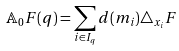Convert formula to latex. <formula><loc_0><loc_0><loc_500><loc_500>\mathbb { A } _ { 0 } F ( q ) = \sum _ { i \in I _ { q } } d ( m _ { i } ) \triangle _ { x _ { i } } F</formula> 